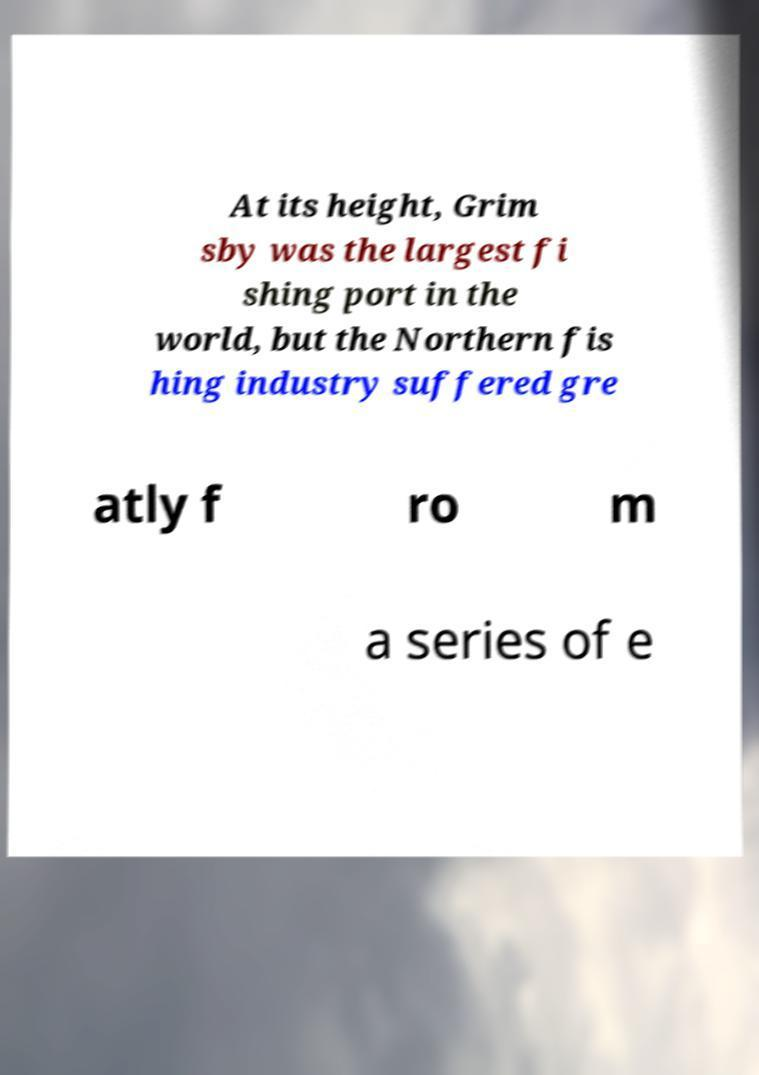Can you accurately transcribe the text from the provided image for me? At its height, Grim sby was the largest fi shing port in the world, but the Northern fis hing industry suffered gre atly f ro m a series of e 